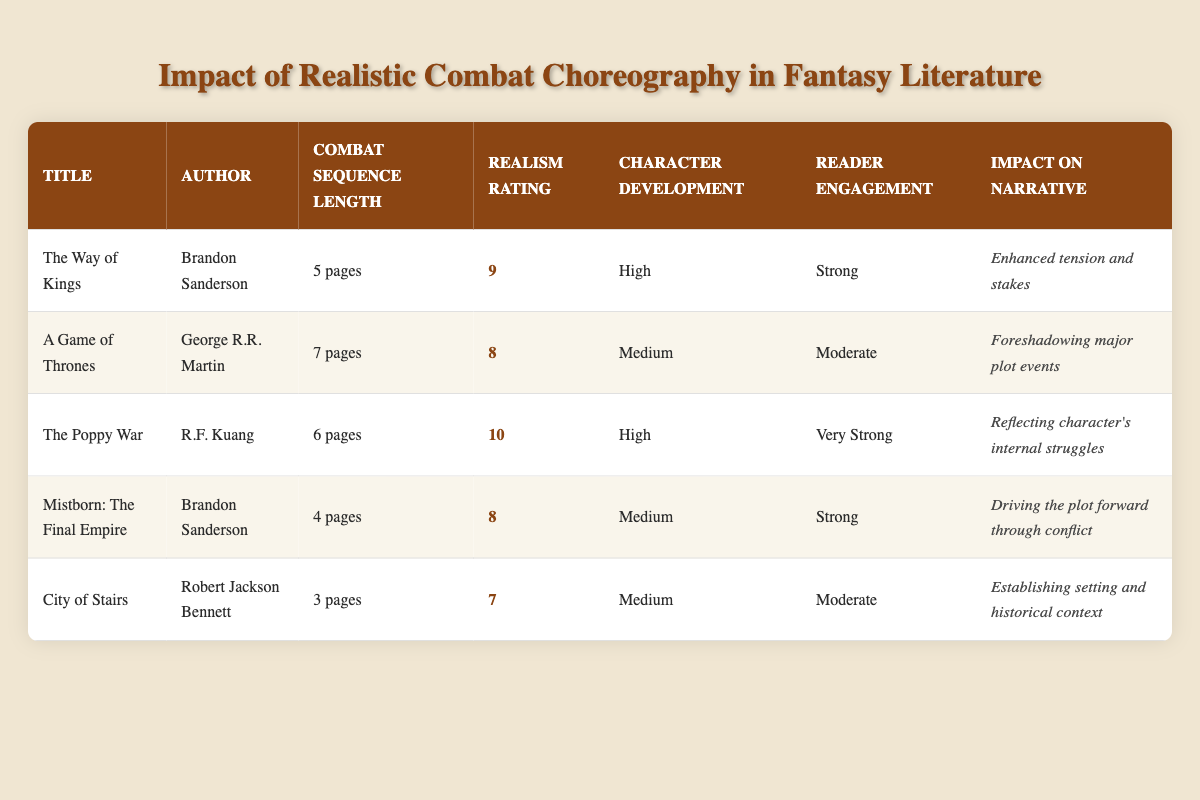What is the combat sequence length of "The Poppy War"? The table shows that "The Poppy War" has a combat sequence length of 6 pages, which is listed under the respective column for that title.
Answer: 6 pages Which book has the highest realism rating? By examining the realism ratings, "The Poppy War" has a rating of 10, which is higher than any other book listed in the table.
Answer: The Poppy War What is the average realism rating of the combat sequences? To find the average realism rating, add the ratings: (9 + 8 + 10 + 8 + 7) = 42. Then divide by the number of books (5): 42 / 5 = 8.4.
Answer: 8.4 Does "City of Stairs" have high character development? The table indicates that "City of Stairs" has a character development rating of Medium, which does not qualify as high. Thus, the answer is no.
Answer: No Which book has both strong reader engagement and high character development? Looking through the table, "The Way of Kings" and "The Poppy War" both have high character development and strong to very strong reader engagement ratings. Both books meet this criterion.
Answer: The Way of Kings and The Poppy War How many pages of combat sequence does the book with the lowest realism rating have? Inspecting the table, "City of Stairs" has the lowest realism rating of 7 and has a combat sequence length of 3 pages.
Answer: 3 pages Which author has written two listed books in this table? Checking the author column, Brandon Sanderson appears in the table for "The Way of Kings" and "Mistborn: The Final Empire." Therefore, he has written two books listed.
Answer: Brandon Sanderson If you combine the combat sequence lengths of "A Game of Thrones" and "Mistborn: The Final Empire," what is the total length? The lengths are 7 pages for "A Game of Thrones" and 4 pages for "Mistborn: The Final Empire." Adding them gives 7 + 4 = 11 pages.
Answer: 11 pages Does "The Poppy War" impact the narrative by establishing historical context? The impact on narrative for "The Poppy War" is listed as reflecting internal struggles, which is different from establishing historical context. Therefore, the answer is no.
Answer: No 